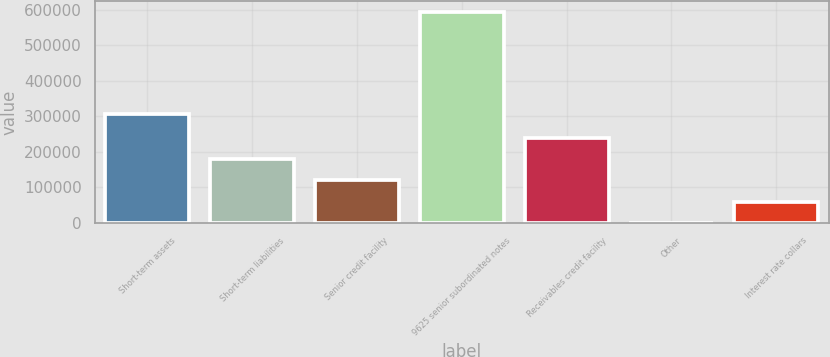Convert chart. <chart><loc_0><loc_0><loc_500><loc_500><bar_chart><fcel>Short-term assets<fcel>Short-term liabilities<fcel>Senior credit facility<fcel>9625 senior subordinated notes<fcel>Receivables credit facility<fcel>Other<fcel>Interest rate collars<nl><fcel>307021<fcel>178349<fcel>118970<fcel>594000<fcel>237728<fcel>213<fcel>59591.7<nl></chart> 